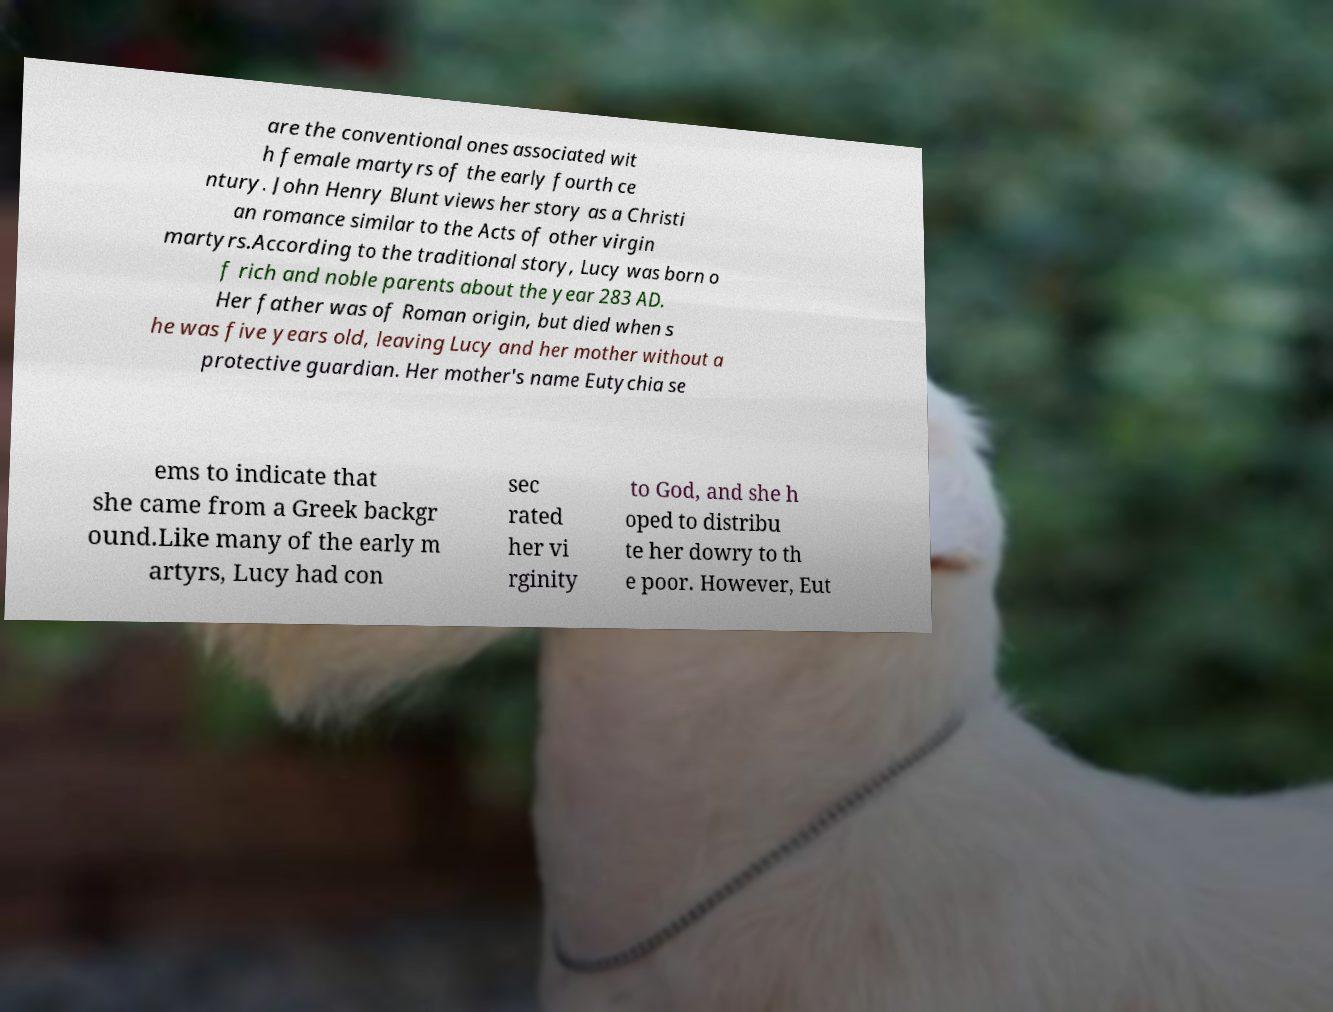Could you assist in decoding the text presented in this image and type it out clearly? are the conventional ones associated wit h female martyrs of the early fourth ce ntury. John Henry Blunt views her story as a Christi an romance similar to the Acts of other virgin martyrs.According to the traditional story, Lucy was born o f rich and noble parents about the year 283 AD. Her father was of Roman origin, but died when s he was five years old, leaving Lucy and her mother without a protective guardian. Her mother's name Eutychia se ems to indicate that she came from a Greek backgr ound.Like many of the early m artyrs, Lucy had con sec rated her vi rginity to God, and she h oped to distribu te her dowry to th e poor. However, Eut 